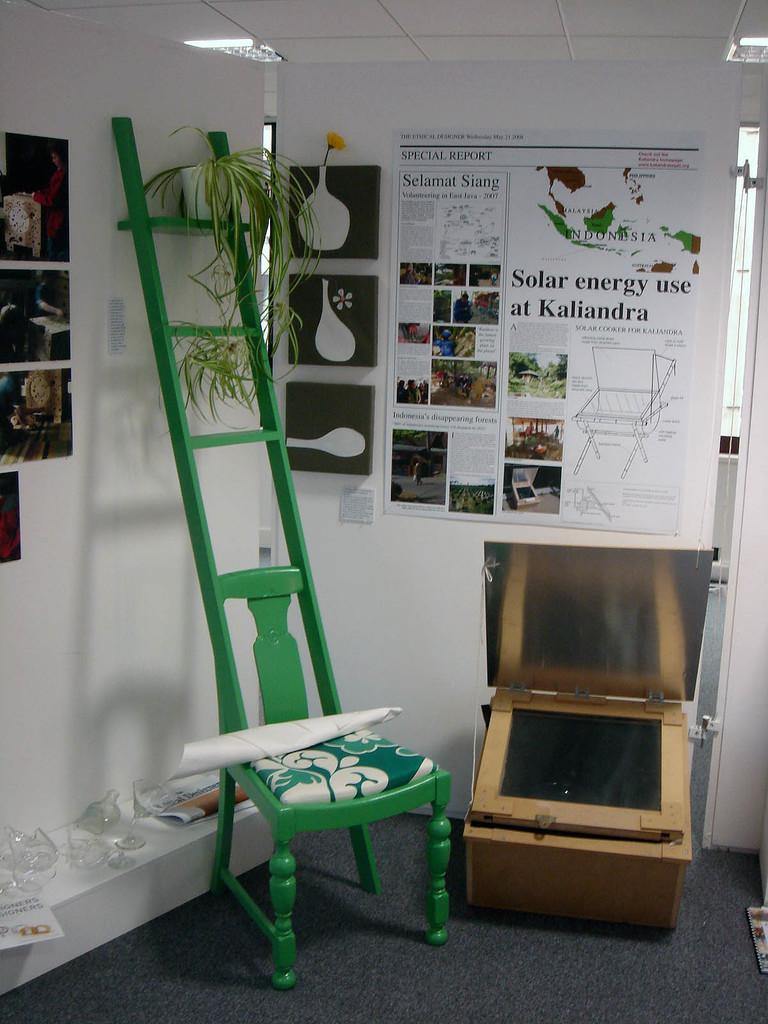Could you give a brief overview of what you see in this image? In this image there is a chair with the ladder. On top of the chair there is a paper. There are a few objects on the platform. There is a wooden object. There are flower pots on the ladder. In the background of the image there are posters on the wall. At the top of the image there are lights. At the bottom of the image there is a mat on the floor. 